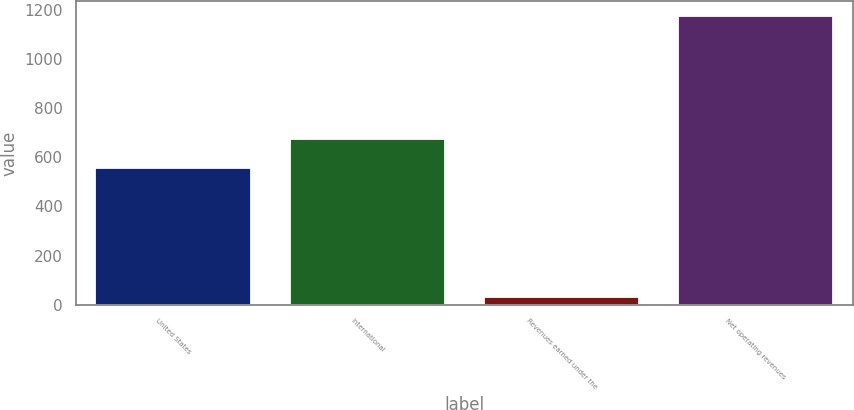Convert chart. <chart><loc_0><loc_0><loc_500><loc_500><bar_chart><fcel>United States<fcel>International<fcel>Revenues earned under the<fcel>Net operating revenues<nl><fcel>559<fcel>673.9<fcel>29<fcel>1178<nl></chart> 